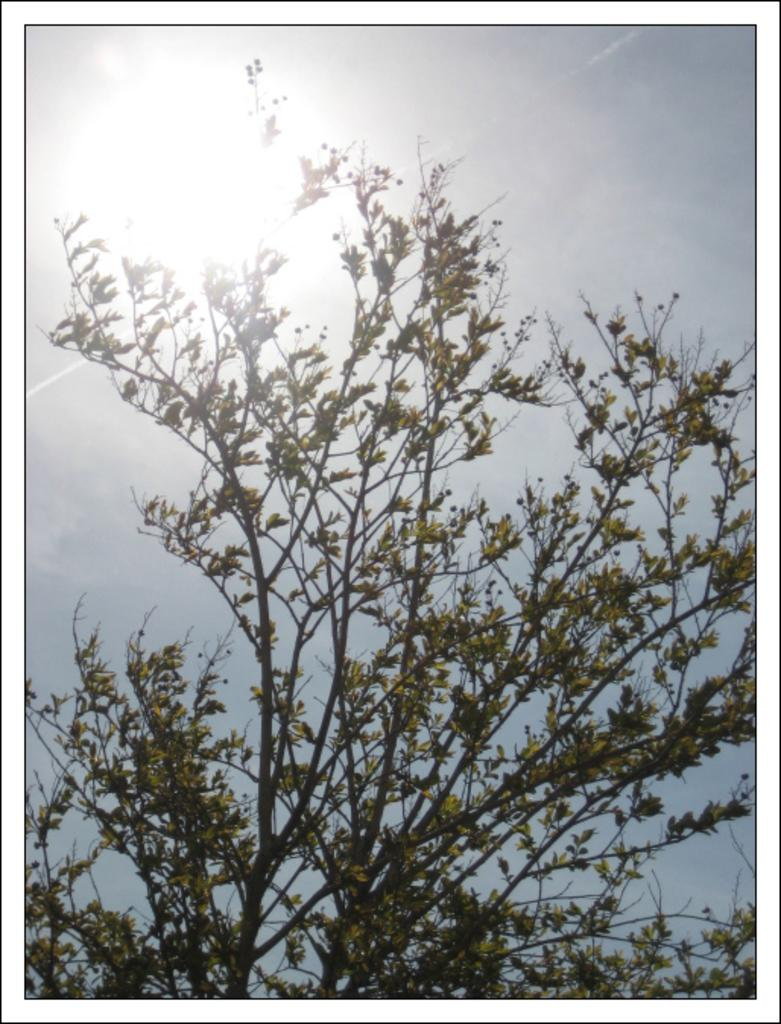What type of vegetation is visible in the image? There are leaves of a tree in the image. What is visible at the top of the image? The sky is visible at the top of the image and it is clear. What action are the leaves of the tree performing in the image? The leaves of the tree are not performing any action in the image; they are stationary on the tree. What is the degree of the sky's visibility in the image? The sky's visibility is not described in terms of degrees in the image; it is simply visible and clear. 